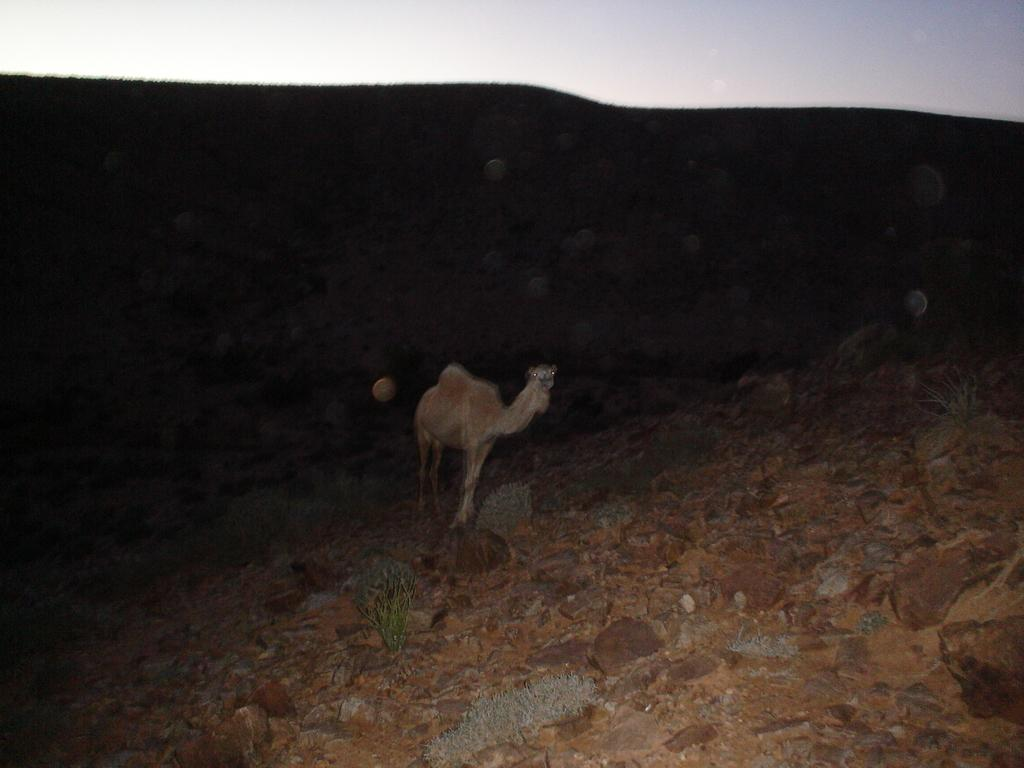What type of creature is in the image? There is an animal in the image. What color is the animal? The animal is brown in color. What can be seen in the background of the image? The background of the image includes the sky. What color is the sky in the image? The sky is white in color. What type of natural formation is visible in the image? There are rocks visible in the image. Can you tell me how many boots are being turned upside down in the image? There are no boots present in the image, so it is not possible to answer that question. 